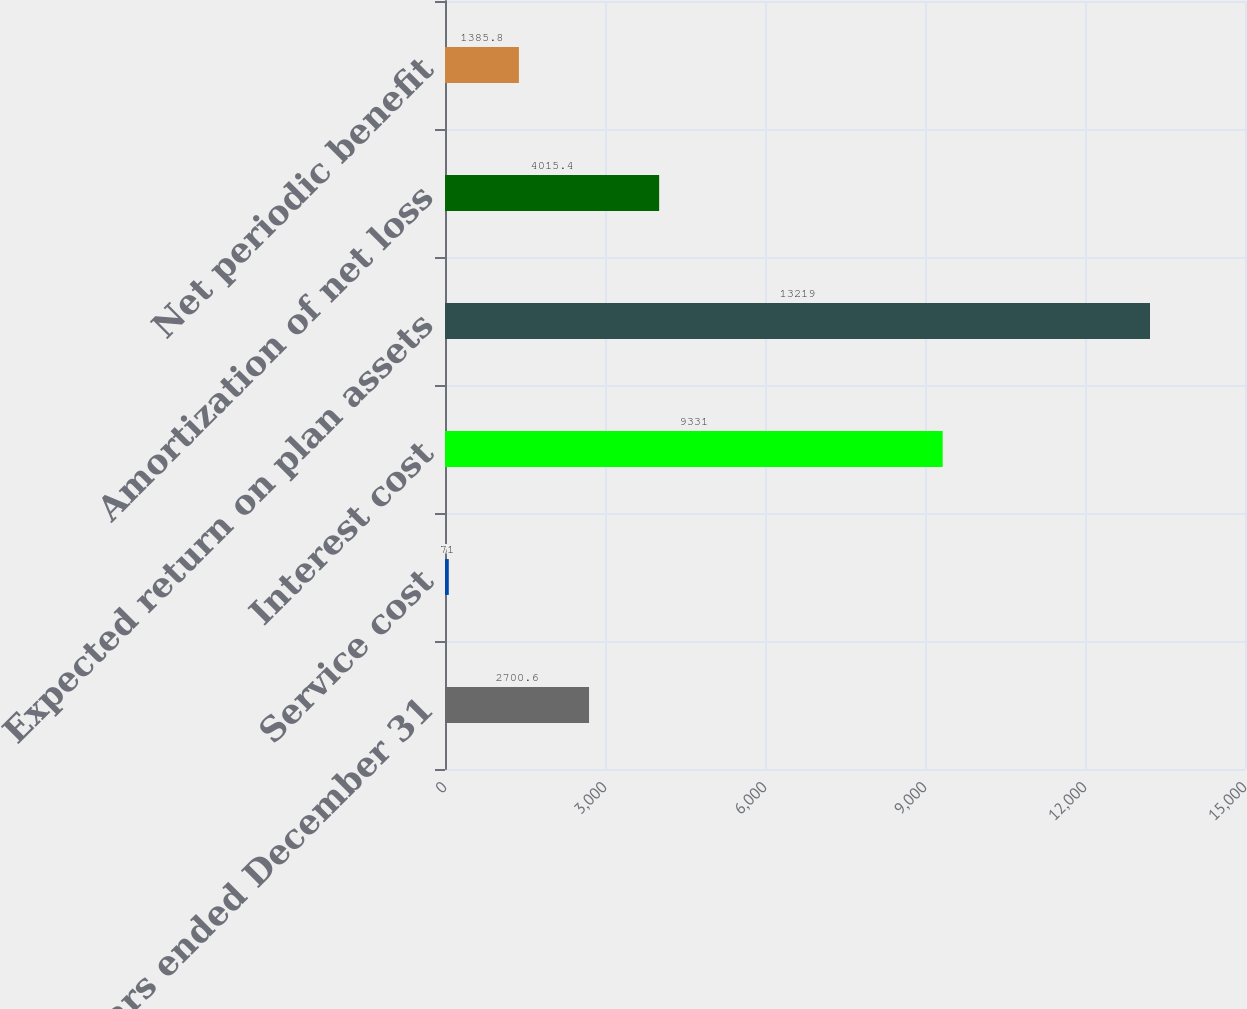Convert chart. <chart><loc_0><loc_0><loc_500><loc_500><bar_chart><fcel>Years ended December 31<fcel>Service cost<fcel>Interest cost<fcel>Expected return on plan assets<fcel>Amortization of net loss<fcel>Net periodic benefit<nl><fcel>2700.6<fcel>71<fcel>9331<fcel>13219<fcel>4015.4<fcel>1385.8<nl></chart> 